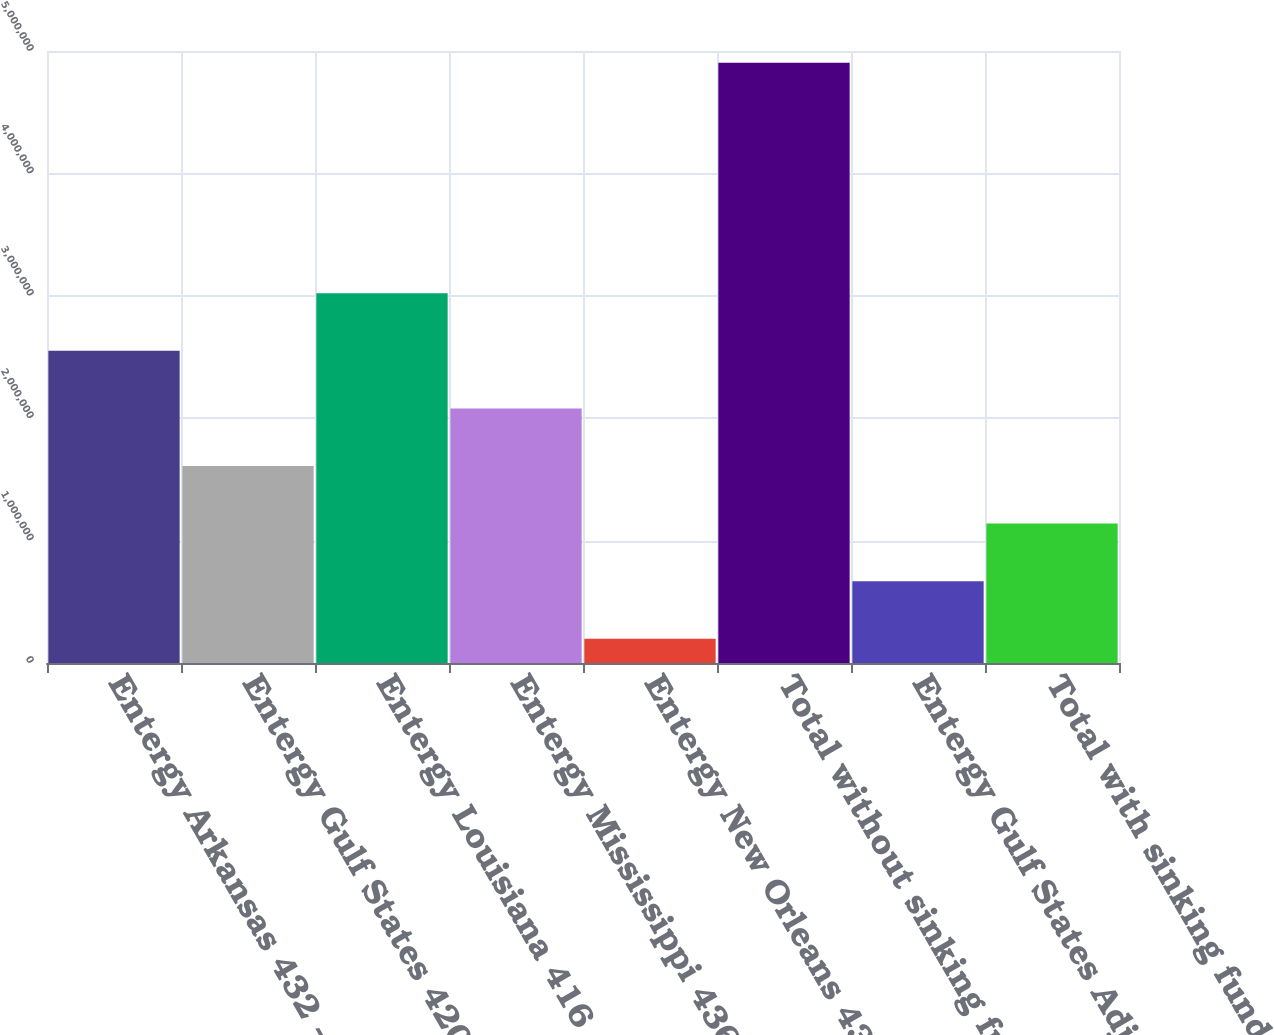Convert chart. <chart><loc_0><loc_0><loc_500><loc_500><bar_chart><fcel>Entergy Arkansas 432 - 788<fcel>Entergy Gulf States 420 - 756<fcel>Entergy Louisiana 416 - 800<fcel>Entergy Mississippi 436 - 836<fcel>Entergy New Orleans 436 - 556<fcel>Total without sinking fund<fcel>Entergy Gulf States Adjustable<fcel>Total with sinking fund<nl><fcel>2.55059e+06<fcel>1.60947e+06<fcel>3.02114e+06<fcel>2.08003e+06<fcel>197798<fcel>4.90337e+06<fcel>668356<fcel>1.13891e+06<nl></chart> 